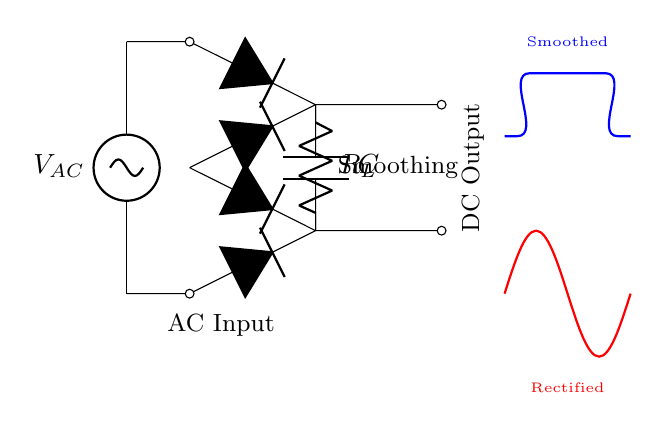What is the component that smooths the output voltage? The component used to smooth the output voltage is the capacitor, represented by the symbol C in the diagram. It charges and discharges to reduce voltage fluctuations.
Answer: Capacitor What type of circuit is this primarily? This circuit is primarily a power supply circuit using a resistor-capacitor filter (RC filter) to convert AC to DC. It includes a smoothing capacitor and load resistor.
Answer: Power supply What is the role of the load resistor? The load resistor R is used to limit the current flowing to the connected appliance, preventing damage and ensuring proper operation by providing a path for current.
Answer: Limit current Which part of the circuit provides the AC input? The AC source labeled V_AC at the top of the circuit provides the alternating current (AC) input needed for the rectification process.
Answer: V_AC What happens to the voltage after it is rectified? After rectification, the voltage waveform is initially jagged, which indicates it has not yet been smoothed. The capacitor serves to reduce these fluctuations, resulting in a more stable output voltage.
Answer: Smoothed What is the significance of the arrows in the bridge rectifier? The arrows in the bridge rectifier indicate the direction of current flow during the positive and negative cycles of the AC input, ensuring that the output voltage remains unidirectional.
Answer: Direction of current How does the capacitor affect the smoothness of the output voltage? The capacitor reduces voltage ripple by charging when the voltage rises and discharging when it falls, thus evening out fluctuations in the output voltage and providing a more stable DC output.
Answer: Reduces ripple 